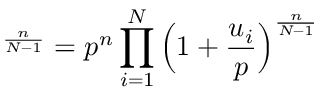Convert formula to latex. <formula><loc_0><loc_0><loc_500><loc_500>{ \L } ^ { \frac { n } { N - 1 } } = p ^ { n } \prod _ { i = 1 } ^ { N } \left ( 1 + \frac { u _ { i } } { p } \right ) ^ { \frac { n } { N - 1 } }</formula> 